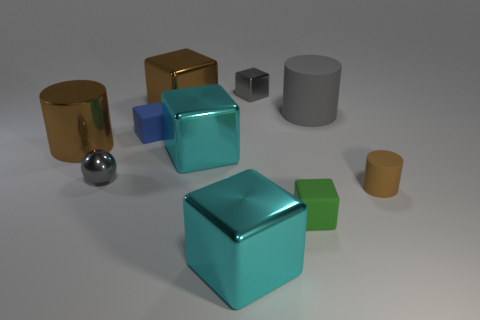Which object seems out of place considering the size and color scheme of this group? When observing the composition of shapes and colors, the small green cube stands out due to its diminutive size compared to the larger objects surrounding it. Additionally, its vibrant green color contrasts sharply with the more muted metallic and neutral tones of the other objects. 